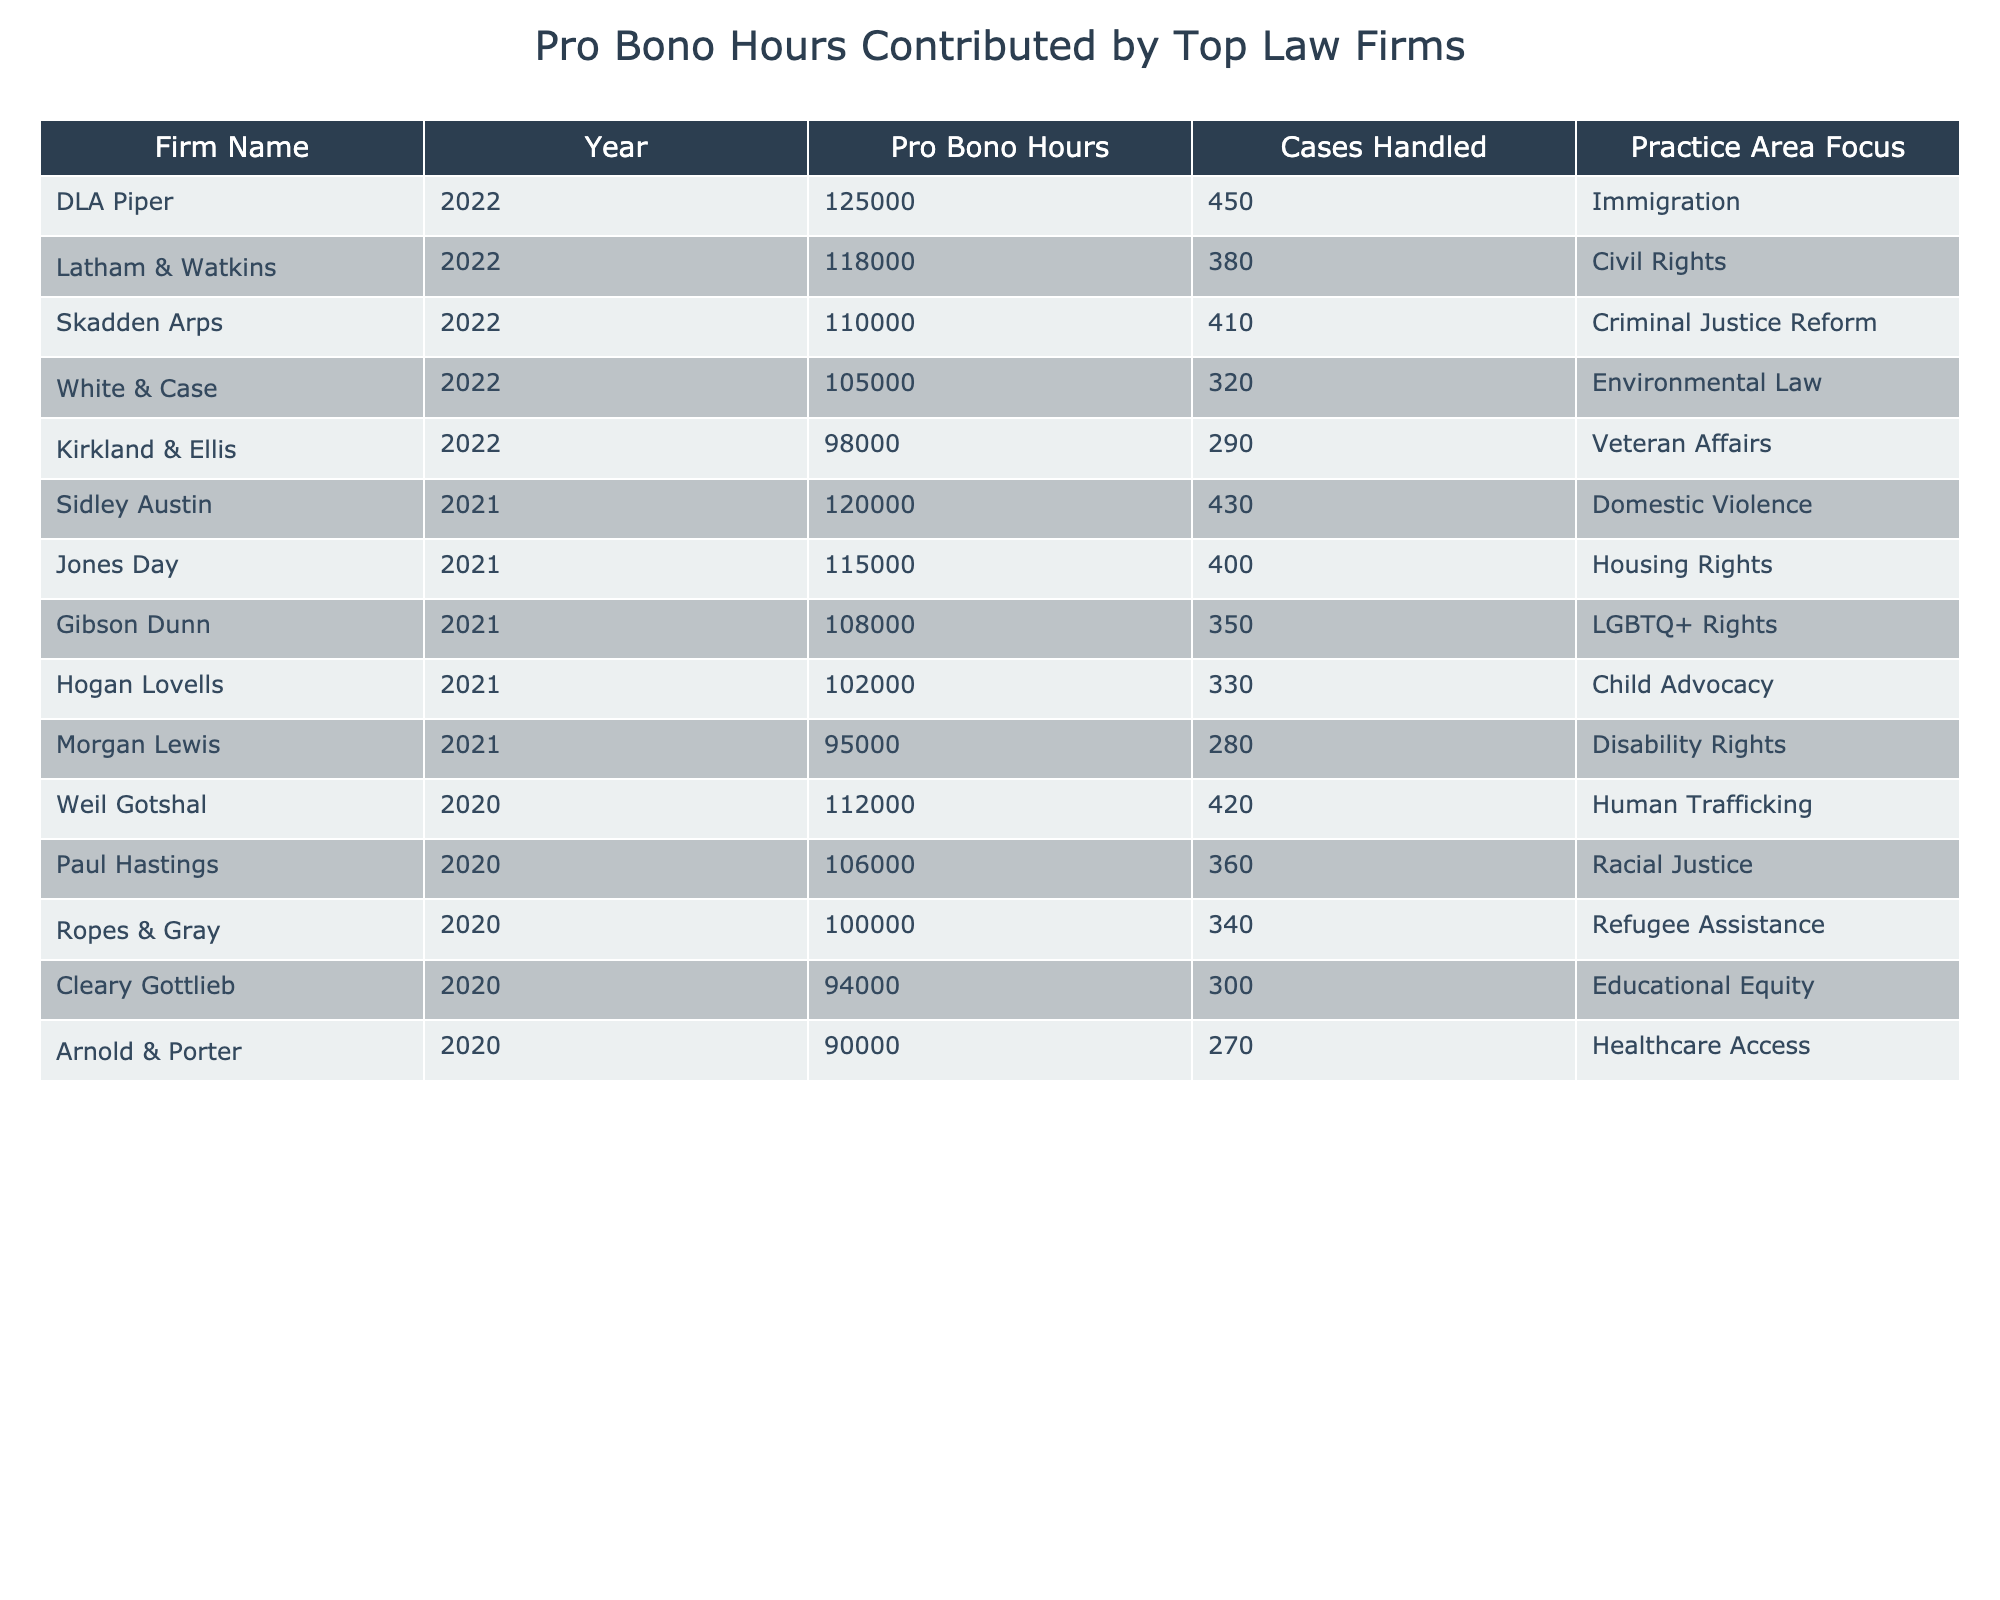What law firm contributed the most pro bono hours in 2022? According to the table, DLA Piper contributed the highest number of pro bono hours, totaling 125,000 hours in 2022.
Answer: DLA Piper What was the total number of pro bono hours contributed by all firms in 2021? By adding the pro bono hours for each firm in 2021: 120,000 + 115,000 + 108,000 + 102,000 + 95,000 = 540,000.
Answer: 540,000 Which practice area had the highest number of cases handled in 2020? In the table for 2020, Weil Gotshal focused on Human Trafficking and handled 420 cases, which is the highest compared to the other practice areas.
Answer: Human Trafficking Did any law firm contribute over 100,000 pro bono hours in 2020? Yes, Weil Gotshal (112,000 hours) and Paul Hastings (106,000 hours) both contributed over 100,000 pro bono hours in 2020.
Answer: Yes What is the average number of cases handled by the firms listed for 2022? The total cases handled in 2022 are 450 + 380 + 410 + 320 + 290 = 1850, divided by 5 firms gives an average of 1850 / 5 = 370.
Answer: 370 Which firm had the lowest pro bono hours in 2021, and how many hours did it contribute? Morgan Lewis had the lowest pro bono hours in 2021, contributing 95,000 hours.
Answer: Morgan Lewis, 95,000 How many more pro bono hours did DLA Piper contribute compared to Kirkland & Ellis in 2022? DLA Piper contributed 125,000 hours and Kirkland & Ellis contributed 98,000 hours. The difference is 125,000 - 98,000 = 27,000 hours.
Answer: 27,000 hours How many cases were handled by Latham & Watkins compared to Hogan Lovells in 2021? Latham & Watkins handled 400 cases while Hogan Lovells handled 330 cases. The difference is 400 - 330 = 70 cases.
Answer: 70 cases What percentage of pro bono hours in 2022 was contributed by Skadden Arps compared to the total pro bono hours of that year? Skadden Arps contributed 110,000 hours out of the total 625,000 hours (125,000 + 118,000 + 110,000 + 105,000 + 98,000). Calculating the percentage gives (110,000 / 625,000) * 100 = 17.6%.
Answer: 17.6% Which firm contributed to the most cases handled in 2021 and how many cases were handled? Sidley Austin handled the most cases in 2021 with a total of 430 cases.
Answer: Sidley Austin, 430 cases 